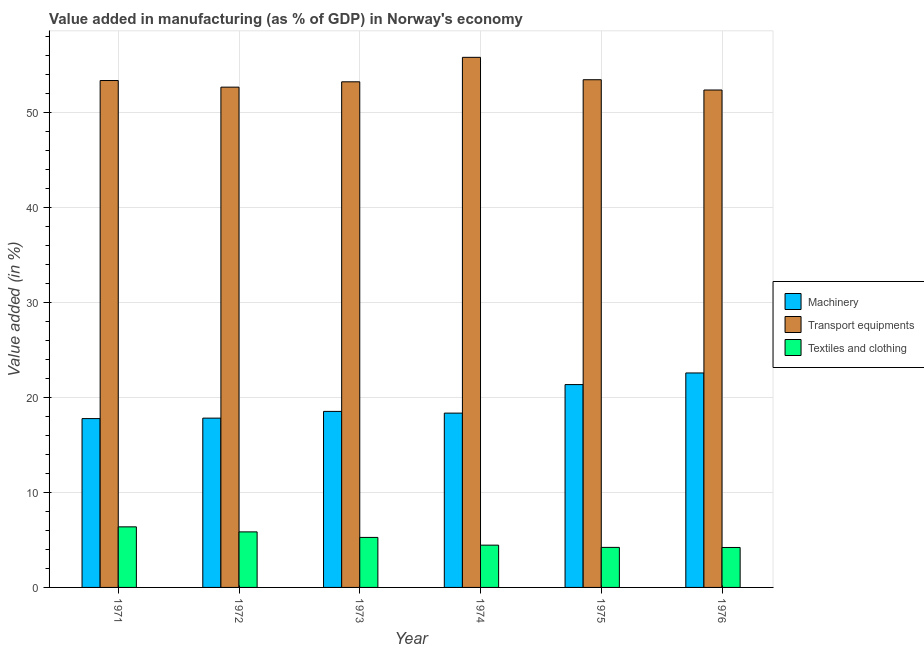How many different coloured bars are there?
Your response must be concise. 3. How many groups of bars are there?
Give a very brief answer. 6. Are the number of bars on each tick of the X-axis equal?
Keep it short and to the point. Yes. What is the label of the 5th group of bars from the left?
Your answer should be compact. 1975. In how many cases, is the number of bars for a given year not equal to the number of legend labels?
Offer a terse response. 0. What is the value added in manufacturing textile and clothing in 1973?
Keep it short and to the point. 5.27. Across all years, what is the maximum value added in manufacturing transport equipments?
Keep it short and to the point. 55.84. Across all years, what is the minimum value added in manufacturing textile and clothing?
Keep it short and to the point. 4.21. In which year was the value added in manufacturing transport equipments maximum?
Give a very brief answer. 1974. In which year was the value added in manufacturing transport equipments minimum?
Give a very brief answer. 1976. What is the total value added in manufacturing transport equipments in the graph?
Keep it short and to the point. 321.11. What is the difference between the value added in manufacturing machinery in 1972 and that in 1974?
Your response must be concise. -0.53. What is the difference between the value added in manufacturing machinery in 1972 and the value added in manufacturing textile and clothing in 1974?
Provide a succinct answer. -0.53. What is the average value added in manufacturing textile and clothing per year?
Make the answer very short. 5.06. In the year 1972, what is the difference between the value added in manufacturing transport equipments and value added in manufacturing textile and clothing?
Offer a very short reply. 0. In how many years, is the value added in manufacturing transport equipments greater than 4 %?
Offer a very short reply. 6. What is the ratio of the value added in manufacturing machinery in 1974 to that in 1976?
Keep it short and to the point. 0.81. Is the value added in manufacturing transport equipments in 1973 less than that in 1976?
Keep it short and to the point. No. Is the difference between the value added in manufacturing machinery in 1971 and 1973 greater than the difference between the value added in manufacturing textile and clothing in 1971 and 1973?
Give a very brief answer. No. What is the difference between the highest and the second highest value added in manufacturing transport equipments?
Ensure brevity in your answer.  2.36. What is the difference between the highest and the lowest value added in manufacturing textile and clothing?
Provide a short and direct response. 2.17. What does the 2nd bar from the left in 1973 represents?
Offer a very short reply. Transport equipments. What does the 2nd bar from the right in 1972 represents?
Make the answer very short. Transport equipments. How many bars are there?
Make the answer very short. 18. Where does the legend appear in the graph?
Provide a short and direct response. Center right. How are the legend labels stacked?
Provide a short and direct response. Vertical. What is the title of the graph?
Make the answer very short. Value added in manufacturing (as % of GDP) in Norway's economy. Does "Unpaid family workers" appear as one of the legend labels in the graph?
Your answer should be very brief. No. What is the label or title of the X-axis?
Your answer should be compact. Year. What is the label or title of the Y-axis?
Give a very brief answer. Value added (in %). What is the Value added (in %) of Machinery in 1971?
Your answer should be compact. 17.79. What is the Value added (in %) in Transport equipments in 1971?
Provide a succinct answer. 53.4. What is the Value added (in %) in Textiles and clothing in 1971?
Give a very brief answer. 6.38. What is the Value added (in %) of Machinery in 1972?
Offer a very short reply. 17.84. What is the Value added (in %) of Transport equipments in 1972?
Offer a terse response. 52.7. What is the Value added (in %) in Textiles and clothing in 1972?
Ensure brevity in your answer.  5.85. What is the Value added (in %) in Machinery in 1973?
Provide a succinct answer. 18.54. What is the Value added (in %) in Transport equipments in 1973?
Your answer should be compact. 53.27. What is the Value added (in %) in Textiles and clothing in 1973?
Offer a terse response. 5.27. What is the Value added (in %) in Machinery in 1974?
Your response must be concise. 18.36. What is the Value added (in %) in Transport equipments in 1974?
Offer a very short reply. 55.84. What is the Value added (in %) in Textiles and clothing in 1974?
Your response must be concise. 4.45. What is the Value added (in %) of Machinery in 1975?
Provide a short and direct response. 21.37. What is the Value added (in %) in Transport equipments in 1975?
Your answer should be compact. 53.49. What is the Value added (in %) in Textiles and clothing in 1975?
Give a very brief answer. 4.22. What is the Value added (in %) in Machinery in 1976?
Make the answer very short. 22.59. What is the Value added (in %) in Transport equipments in 1976?
Provide a succinct answer. 52.4. What is the Value added (in %) in Textiles and clothing in 1976?
Keep it short and to the point. 4.21. Across all years, what is the maximum Value added (in %) in Machinery?
Your answer should be compact. 22.59. Across all years, what is the maximum Value added (in %) in Transport equipments?
Your response must be concise. 55.84. Across all years, what is the maximum Value added (in %) of Textiles and clothing?
Provide a succinct answer. 6.38. Across all years, what is the minimum Value added (in %) of Machinery?
Give a very brief answer. 17.79. Across all years, what is the minimum Value added (in %) in Transport equipments?
Offer a terse response. 52.4. Across all years, what is the minimum Value added (in %) of Textiles and clothing?
Give a very brief answer. 4.21. What is the total Value added (in %) of Machinery in the graph?
Your response must be concise. 116.49. What is the total Value added (in %) of Transport equipments in the graph?
Provide a short and direct response. 321.11. What is the total Value added (in %) of Textiles and clothing in the graph?
Provide a succinct answer. 30.38. What is the difference between the Value added (in %) of Machinery in 1971 and that in 1972?
Offer a terse response. -0.05. What is the difference between the Value added (in %) of Transport equipments in 1971 and that in 1972?
Provide a short and direct response. 0.7. What is the difference between the Value added (in %) of Textiles and clothing in 1971 and that in 1972?
Your response must be concise. 0.53. What is the difference between the Value added (in %) in Machinery in 1971 and that in 1973?
Your answer should be very brief. -0.76. What is the difference between the Value added (in %) in Transport equipments in 1971 and that in 1973?
Keep it short and to the point. 0.14. What is the difference between the Value added (in %) of Textiles and clothing in 1971 and that in 1973?
Ensure brevity in your answer.  1.11. What is the difference between the Value added (in %) in Machinery in 1971 and that in 1974?
Your answer should be very brief. -0.58. What is the difference between the Value added (in %) of Transport equipments in 1971 and that in 1974?
Give a very brief answer. -2.44. What is the difference between the Value added (in %) of Textiles and clothing in 1971 and that in 1974?
Your answer should be compact. 1.93. What is the difference between the Value added (in %) in Machinery in 1971 and that in 1975?
Make the answer very short. -3.58. What is the difference between the Value added (in %) of Transport equipments in 1971 and that in 1975?
Provide a short and direct response. -0.08. What is the difference between the Value added (in %) in Textiles and clothing in 1971 and that in 1975?
Give a very brief answer. 2.16. What is the difference between the Value added (in %) in Machinery in 1971 and that in 1976?
Offer a very short reply. -4.81. What is the difference between the Value added (in %) of Textiles and clothing in 1971 and that in 1976?
Provide a succinct answer. 2.17. What is the difference between the Value added (in %) of Machinery in 1972 and that in 1973?
Offer a very short reply. -0.71. What is the difference between the Value added (in %) in Transport equipments in 1972 and that in 1973?
Your response must be concise. -0.56. What is the difference between the Value added (in %) of Textiles and clothing in 1972 and that in 1973?
Your answer should be very brief. 0.58. What is the difference between the Value added (in %) in Machinery in 1972 and that in 1974?
Make the answer very short. -0.53. What is the difference between the Value added (in %) of Transport equipments in 1972 and that in 1974?
Provide a succinct answer. -3.14. What is the difference between the Value added (in %) in Textiles and clothing in 1972 and that in 1974?
Your answer should be compact. 1.4. What is the difference between the Value added (in %) in Machinery in 1972 and that in 1975?
Provide a short and direct response. -3.53. What is the difference between the Value added (in %) in Transport equipments in 1972 and that in 1975?
Make the answer very short. -0.78. What is the difference between the Value added (in %) in Textiles and clothing in 1972 and that in 1975?
Give a very brief answer. 1.63. What is the difference between the Value added (in %) in Machinery in 1972 and that in 1976?
Your response must be concise. -4.76. What is the difference between the Value added (in %) of Transport equipments in 1972 and that in 1976?
Ensure brevity in your answer.  0.3. What is the difference between the Value added (in %) in Textiles and clothing in 1972 and that in 1976?
Ensure brevity in your answer.  1.64. What is the difference between the Value added (in %) of Machinery in 1973 and that in 1974?
Your response must be concise. 0.18. What is the difference between the Value added (in %) of Transport equipments in 1973 and that in 1974?
Give a very brief answer. -2.58. What is the difference between the Value added (in %) in Textiles and clothing in 1973 and that in 1974?
Ensure brevity in your answer.  0.81. What is the difference between the Value added (in %) in Machinery in 1973 and that in 1975?
Provide a short and direct response. -2.83. What is the difference between the Value added (in %) of Transport equipments in 1973 and that in 1975?
Your answer should be compact. -0.22. What is the difference between the Value added (in %) in Textiles and clothing in 1973 and that in 1975?
Provide a short and direct response. 1.05. What is the difference between the Value added (in %) of Machinery in 1973 and that in 1976?
Offer a terse response. -4.05. What is the difference between the Value added (in %) in Transport equipments in 1973 and that in 1976?
Offer a very short reply. 0.86. What is the difference between the Value added (in %) in Textiles and clothing in 1973 and that in 1976?
Your answer should be compact. 1.06. What is the difference between the Value added (in %) in Machinery in 1974 and that in 1975?
Ensure brevity in your answer.  -3.01. What is the difference between the Value added (in %) of Transport equipments in 1974 and that in 1975?
Give a very brief answer. 2.36. What is the difference between the Value added (in %) of Textiles and clothing in 1974 and that in 1975?
Your answer should be compact. 0.24. What is the difference between the Value added (in %) in Machinery in 1974 and that in 1976?
Offer a very short reply. -4.23. What is the difference between the Value added (in %) in Transport equipments in 1974 and that in 1976?
Ensure brevity in your answer.  3.44. What is the difference between the Value added (in %) of Textiles and clothing in 1974 and that in 1976?
Your answer should be compact. 0.24. What is the difference between the Value added (in %) of Machinery in 1975 and that in 1976?
Offer a terse response. -1.22. What is the difference between the Value added (in %) of Transport equipments in 1975 and that in 1976?
Make the answer very short. 1.08. What is the difference between the Value added (in %) of Textiles and clothing in 1975 and that in 1976?
Ensure brevity in your answer.  0.01. What is the difference between the Value added (in %) of Machinery in 1971 and the Value added (in %) of Transport equipments in 1972?
Offer a very short reply. -34.92. What is the difference between the Value added (in %) of Machinery in 1971 and the Value added (in %) of Textiles and clothing in 1972?
Provide a succinct answer. 11.93. What is the difference between the Value added (in %) of Transport equipments in 1971 and the Value added (in %) of Textiles and clothing in 1972?
Provide a succinct answer. 47.55. What is the difference between the Value added (in %) in Machinery in 1971 and the Value added (in %) in Transport equipments in 1973?
Provide a short and direct response. -35.48. What is the difference between the Value added (in %) of Machinery in 1971 and the Value added (in %) of Textiles and clothing in 1973?
Make the answer very short. 12.52. What is the difference between the Value added (in %) in Transport equipments in 1971 and the Value added (in %) in Textiles and clothing in 1973?
Give a very brief answer. 48.13. What is the difference between the Value added (in %) in Machinery in 1971 and the Value added (in %) in Transport equipments in 1974?
Your answer should be compact. -38.06. What is the difference between the Value added (in %) of Machinery in 1971 and the Value added (in %) of Textiles and clothing in 1974?
Your answer should be very brief. 13.33. What is the difference between the Value added (in %) of Transport equipments in 1971 and the Value added (in %) of Textiles and clothing in 1974?
Offer a very short reply. 48.95. What is the difference between the Value added (in %) in Machinery in 1971 and the Value added (in %) in Transport equipments in 1975?
Offer a very short reply. -35.7. What is the difference between the Value added (in %) in Machinery in 1971 and the Value added (in %) in Textiles and clothing in 1975?
Offer a very short reply. 13.57. What is the difference between the Value added (in %) in Transport equipments in 1971 and the Value added (in %) in Textiles and clothing in 1975?
Give a very brief answer. 49.18. What is the difference between the Value added (in %) of Machinery in 1971 and the Value added (in %) of Transport equipments in 1976?
Offer a very short reply. -34.62. What is the difference between the Value added (in %) of Machinery in 1971 and the Value added (in %) of Textiles and clothing in 1976?
Ensure brevity in your answer.  13.58. What is the difference between the Value added (in %) of Transport equipments in 1971 and the Value added (in %) of Textiles and clothing in 1976?
Offer a very short reply. 49.19. What is the difference between the Value added (in %) in Machinery in 1972 and the Value added (in %) in Transport equipments in 1973?
Make the answer very short. -35.43. What is the difference between the Value added (in %) of Machinery in 1972 and the Value added (in %) of Textiles and clothing in 1973?
Make the answer very short. 12.57. What is the difference between the Value added (in %) of Transport equipments in 1972 and the Value added (in %) of Textiles and clothing in 1973?
Offer a very short reply. 47.44. What is the difference between the Value added (in %) of Machinery in 1972 and the Value added (in %) of Transport equipments in 1974?
Make the answer very short. -38.01. What is the difference between the Value added (in %) of Machinery in 1972 and the Value added (in %) of Textiles and clothing in 1974?
Your response must be concise. 13.38. What is the difference between the Value added (in %) in Transport equipments in 1972 and the Value added (in %) in Textiles and clothing in 1974?
Give a very brief answer. 48.25. What is the difference between the Value added (in %) of Machinery in 1972 and the Value added (in %) of Transport equipments in 1975?
Your response must be concise. -35.65. What is the difference between the Value added (in %) of Machinery in 1972 and the Value added (in %) of Textiles and clothing in 1975?
Your answer should be very brief. 13.62. What is the difference between the Value added (in %) of Transport equipments in 1972 and the Value added (in %) of Textiles and clothing in 1975?
Your answer should be compact. 48.49. What is the difference between the Value added (in %) in Machinery in 1972 and the Value added (in %) in Transport equipments in 1976?
Make the answer very short. -34.57. What is the difference between the Value added (in %) of Machinery in 1972 and the Value added (in %) of Textiles and clothing in 1976?
Ensure brevity in your answer.  13.63. What is the difference between the Value added (in %) in Transport equipments in 1972 and the Value added (in %) in Textiles and clothing in 1976?
Your response must be concise. 48.49. What is the difference between the Value added (in %) in Machinery in 1973 and the Value added (in %) in Transport equipments in 1974?
Give a very brief answer. -37.3. What is the difference between the Value added (in %) of Machinery in 1973 and the Value added (in %) of Textiles and clothing in 1974?
Give a very brief answer. 14.09. What is the difference between the Value added (in %) of Transport equipments in 1973 and the Value added (in %) of Textiles and clothing in 1974?
Give a very brief answer. 48.81. What is the difference between the Value added (in %) of Machinery in 1973 and the Value added (in %) of Transport equipments in 1975?
Offer a terse response. -34.94. What is the difference between the Value added (in %) in Machinery in 1973 and the Value added (in %) in Textiles and clothing in 1975?
Ensure brevity in your answer.  14.33. What is the difference between the Value added (in %) in Transport equipments in 1973 and the Value added (in %) in Textiles and clothing in 1975?
Your answer should be very brief. 49.05. What is the difference between the Value added (in %) of Machinery in 1973 and the Value added (in %) of Transport equipments in 1976?
Your answer should be very brief. -33.86. What is the difference between the Value added (in %) in Machinery in 1973 and the Value added (in %) in Textiles and clothing in 1976?
Offer a terse response. 14.33. What is the difference between the Value added (in %) of Transport equipments in 1973 and the Value added (in %) of Textiles and clothing in 1976?
Your answer should be very brief. 49.06. What is the difference between the Value added (in %) of Machinery in 1974 and the Value added (in %) of Transport equipments in 1975?
Your answer should be compact. -35.12. What is the difference between the Value added (in %) of Machinery in 1974 and the Value added (in %) of Textiles and clothing in 1975?
Give a very brief answer. 14.15. What is the difference between the Value added (in %) in Transport equipments in 1974 and the Value added (in %) in Textiles and clothing in 1975?
Your answer should be very brief. 51.63. What is the difference between the Value added (in %) in Machinery in 1974 and the Value added (in %) in Transport equipments in 1976?
Give a very brief answer. -34.04. What is the difference between the Value added (in %) in Machinery in 1974 and the Value added (in %) in Textiles and clothing in 1976?
Provide a short and direct response. 14.15. What is the difference between the Value added (in %) in Transport equipments in 1974 and the Value added (in %) in Textiles and clothing in 1976?
Offer a very short reply. 51.64. What is the difference between the Value added (in %) in Machinery in 1975 and the Value added (in %) in Transport equipments in 1976?
Ensure brevity in your answer.  -31.03. What is the difference between the Value added (in %) in Machinery in 1975 and the Value added (in %) in Textiles and clothing in 1976?
Provide a short and direct response. 17.16. What is the difference between the Value added (in %) of Transport equipments in 1975 and the Value added (in %) of Textiles and clothing in 1976?
Give a very brief answer. 49.28. What is the average Value added (in %) in Machinery per year?
Your answer should be compact. 19.42. What is the average Value added (in %) in Transport equipments per year?
Offer a very short reply. 53.52. What is the average Value added (in %) of Textiles and clothing per year?
Offer a terse response. 5.06. In the year 1971, what is the difference between the Value added (in %) of Machinery and Value added (in %) of Transport equipments?
Your response must be concise. -35.62. In the year 1971, what is the difference between the Value added (in %) in Machinery and Value added (in %) in Textiles and clothing?
Give a very brief answer. 11.4. In the year 1971, what is the difference between the Value added (in %) in Transport equipments and Value added (in %) in Textiles and clothing?
Give a very brief answer. 47.02. In the year 1972, what is the difference between the Value added (in %) in Machinery and Value added (in %) in Transport equipments?
Your answer should be very brief. -34.87. In the year 1972, what is the difference between the Value added (in %) in Machinery and Value added (in %) in Textiles and clothing?
Ensure brevity in your answer.  11.98. In the year 1972, what is the difference between the Value added (in %) in Transport equipments and Value added (in %) in Textiles and clothing?
Give a very brief answer. 46.85. In the year 1973, what is the difference between the Value added (in %) in Machinery and Value added (in %) in Transport equipments?
Your answer should be very brief. -34.72. In the year 1973, what is the difference between the Value added (in %) of Machinery and Value added (in %) of Textiles and clothing?
Your answer should be compact. 13.28. In the year 1973, what is the difference between the Value added (in %) of Transport equipments and Value added (in %) of Textiles and clothing?
Ensure brevity in your answer.  48. In the year 1974, what is the difference between the Value added (in %) of Machinery and Value added (in %) of Transport equipments?
Give a very brief answer. -37.48. In the year 1974, what is the difference between the Value added (in %) in Machinery and Value added (in %) in Textiles and clothing?
Your answer should be compact. 13.91. In the year 1974, what is the difference between the Value added (in %) in Transport equipments and Value added (in %) in Textiles and clothing?
Keep it short and to the point. 51.39. In the year 1975, what is the difference between the Value added (in %) in Machinery and Value added (in %) in Transport equipments?
Keep it short and to the point. -32.12. In the year 1975, what is the difference between the Value added (in %) in Machinery and Value added (in %) in Textiles and clothing?
Your response must be concise. 17.15. In the year 1975, what is the difference between the Value added (in %) in Transport equipments and Value added (in %) in Textiles and clothing?
Ensure brevity in your answer.  49.27. In the year 1976, what is the difference between the Value added (in %) in Machinery and Value added (in %) in Transport equipments?
Make the answer very short. -29.81. In the year 1976, what is the difference between the Value added (in %) of Machinery and Value added (in %) of Textiles and clothing?
Your answer should be very brief. 18.38. In the year 1976, what is the difference between the Value added (in %) of Transport equipments and Value added (in %) of Textiles and clothing?
Offer a very short reply. 48.19. What is the ratio of the Value added (in %) of Transport equipments in 1971 to that in 1972?
Make the answer very short. 1.01. What is the ratio of the Value added (in %) of Textiles and clothing in 1971 to that in 1972?
Offer a very short reply. 1.09. What is the ratio of the Value added (in %) of Machinery in 1971 to that in 1973?
Provide a succinct answer. 0.96. What is the ratio of the Value added (in %) of Textiles and clothing in 1971 to that in 1973?
Ensure brevity in your answer.  1.21. What is the ratio of the Value added (in %) of Machinery in 1971 to that in 1974?
Ensure brevity in your answer.  0.97. What is the ratio of the Value added (in %) of Transport equipments in 1971 to that in 1974?
Give a very brief answer. 0.96. What is the ratio of the Value added (in %) of Textiles and clothing in 1971 to that in 1974?
Make the answer very short. 1.43. What is the ratio of the Value added (in %) in Machinery in 1971 to that in 1975?
Give a very brief answer. 0.83. What is the ratio of the Value added (in %) of Textiles and clothing in 1971 to that in 1975?
Offer a terse response. 1.51. What is the ratio of the Value added (in %) in Machinery in 1971 to that in 1976?
Your answer should be compact. 0.79. What is the ratio of the Value added (in %) in Transport equipments in 1971 to that in 1976?
Ensure brevity in your answer.  1.02. What is the ratio of the Value added (in %) in Textiles and clothing in 1971 to that in 1976?
Provide a short and direct response. 1.52. What is the ratio of the Value added (in %) in Machinery in 1972 to that in 1973?
Provide a succinct answer. 0.96. What is the ratio of the Value added (in %) of Textiles and clothing in 1972 to that in 1973?
Provide a short and direct response. 1.11. What is the ratio of the Value added (in %) in Machinery in 1972 to that in 1974?
Make the answer very short. 0.97. What is the ratio of the Value added (in %) of Transport equipments in 1972 to that in 1974?
Provide a short and direct response. 0.94. What is the ratio of the Value added (in %) in Textiles and clothing in 1972 to that in 1974?
Make the answer very short. 1.31. What is the ratio of the Value added (in %) in Machinery in 1972 to that in 1975?
Your response must be concise. 0.83. What is the ratio of the Value added (in %) in Transport equipments in 1972 to that in 1975?
Your answer should be compact. 0.99. What is the ratio of the Value added (in %) of Textiles and clothing in 1972 to that in 1975?
Provide a short and direct response. 1.39. What is the ratio of the Value added (in %) in Machinery in 1972 to that in 1976?
Offer a terse response. 0.79. What is the ratio of the Value added (in %) in Transport equipments in 1972 to that in 1976?
Your response must be concise. 1.01. What is the ratio of the Value added (in %) in Textiles and clothing in 1972 to that in 1976?
Offer a terse response. 1.39. What is the ratio of the Value added (in %) in Machinery in 1973 to that in 1974?
Make the answer very short. 1.01. What is the ratio of the Value added (in %) in Transport equipments in 1973 to that in 1974?
Your answer should be compact. 0.95. What is the ratio of the Value added (in %) in Textiles and clothing in 1973 to that in 1974?
Offer a terse response. 1.18. What is the ratio of the Value added (in %) of Machinery in 1973 to that in 1975?
Offer a very short reply. 0.87. What is the ratio of the Value added (in %) in Transport equipments in 1973 to that in 1975?
Offer a terse response. 1. What is the ratio of the Value added (in %) in Textiles and clothing in 1973 to that in 1975?
Provide a succinct answer. 1.25. What is the ratio of the Value added (in %) of Machinery in 1973 to that in 1976?
Provide a succinct answer. 0.82. What is the ratio of the Value added (in %) in Transport equipments in 1973 to that in 1976?
Keep it short and to the point. 1.02. What is the ratio of the Value added (in %) in Textiles and clothing in 1973 to that in 1976?
Your answer should be very brief. 1.25. What is the ratio of the Value added (in %) of Machinery in 1974 to that in 1975?
Make the answer very short. 0.86. What is the ratio of the Value added (in %) in Transport equipments in 1974 to that in 1975?
Make the answer very short. 1.04. What is the ratio of the Value added (in %) of Textiles and clothing in 1974 to that in 1975?
Your response must be concise. 1.06. What is the ratio of the Value added (in %) of Machinery in 1974 to that in 1976?
Make the answer very short. 0.81. What is the ratio of the Value added (in %) of Transport equipments in 1974 to that in 1976?
Make the answer very short. 1.07. What is the ratio of the Value added (in %) of Textiles and clothing in 1974 to that in 1976?
Keep it short and to the point. 1.06. What is the ratio of the Value added (in %) of Machinery in 1975 to that in 1976?
Offer a very short reply. 0.95. What is the ratio of the Value added (in %) of Transport equipments in 1975 to that in 1976?
Ensure brevity in your answer.  1.02. What is the difference between the highest and the second highest Value added (in %) of Machinery?
Your response must be concise. 1.22. What is the difference between the highest and the second highest Value added (in %) in Transport equipments?
Keep it short and to the point. 2.36. What is the difference between the highest and the second highest Value added (in %) of Textiles and clothing?
Provide a short and direct response. 0.53. What is the difference between the highest and the lowest Value added (in %) in Machinery?
Offer a very short reply. 4.81. What is the difference between the highest and the lowest Value added (in %) of Transport equipments?
Provide a short and direct response. 3.44. What is the difference between the highest and the lowest Value added (in %) of Textiles and clothing?
Keep it short and to the point. 2.17. 